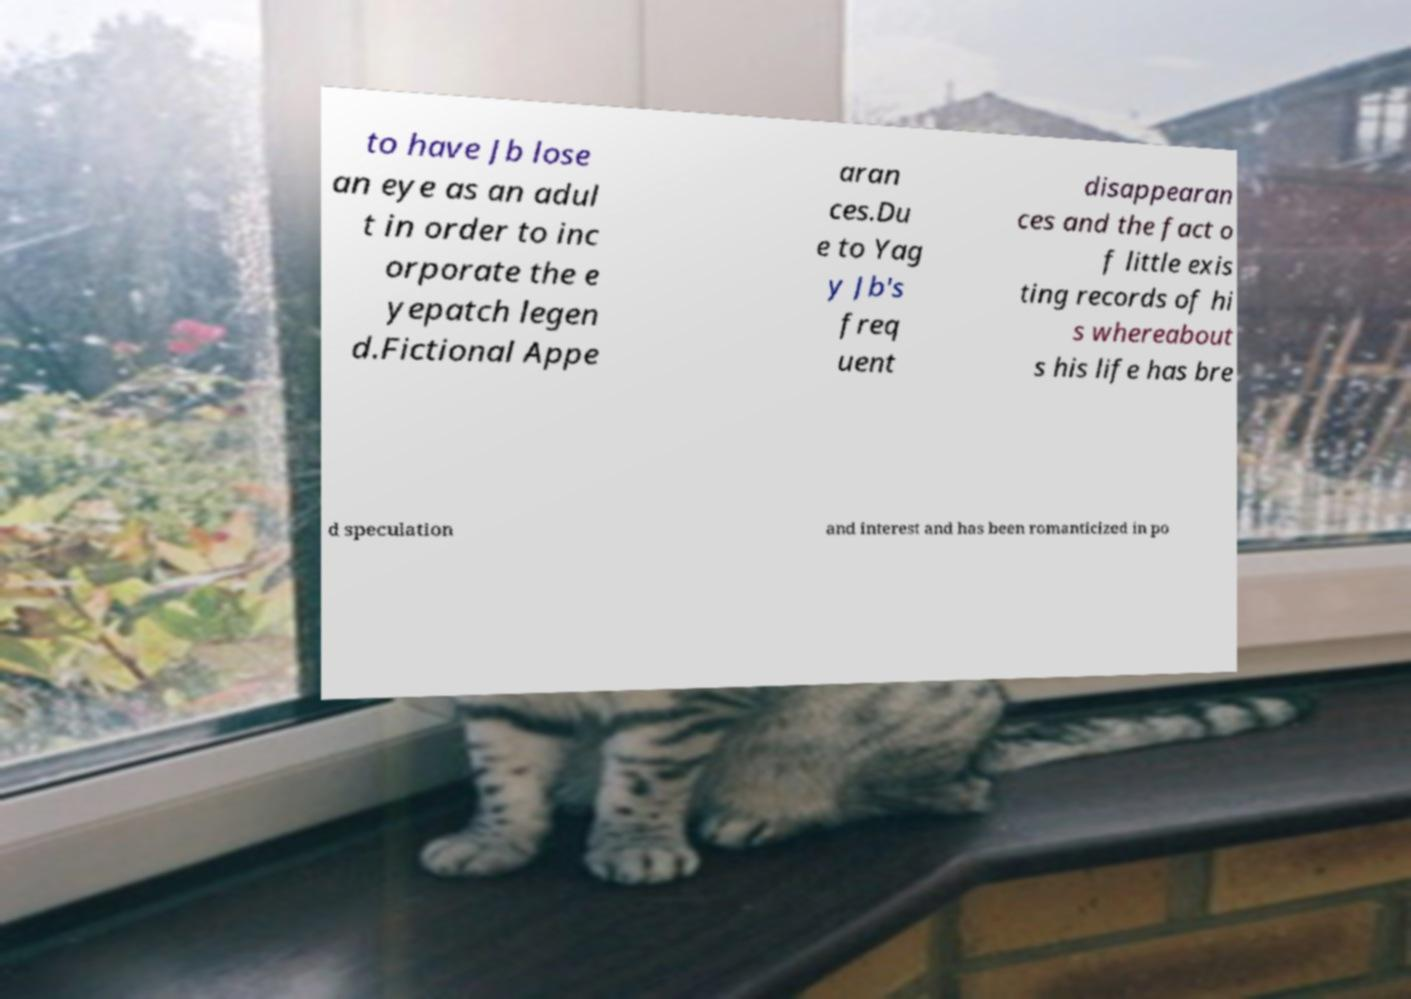Please identify and transcribe the text found in this image. to have Jb lose an eye as an adul t in order to inc orporate the e yepatch legen d.Fictional Appe aran ces.Du e to Yag y Jb's freq uent disappearan ces and the fact o f little exis ting records of hi s whereabout s his life has bre d speculation and interest and has been romanticized in po 